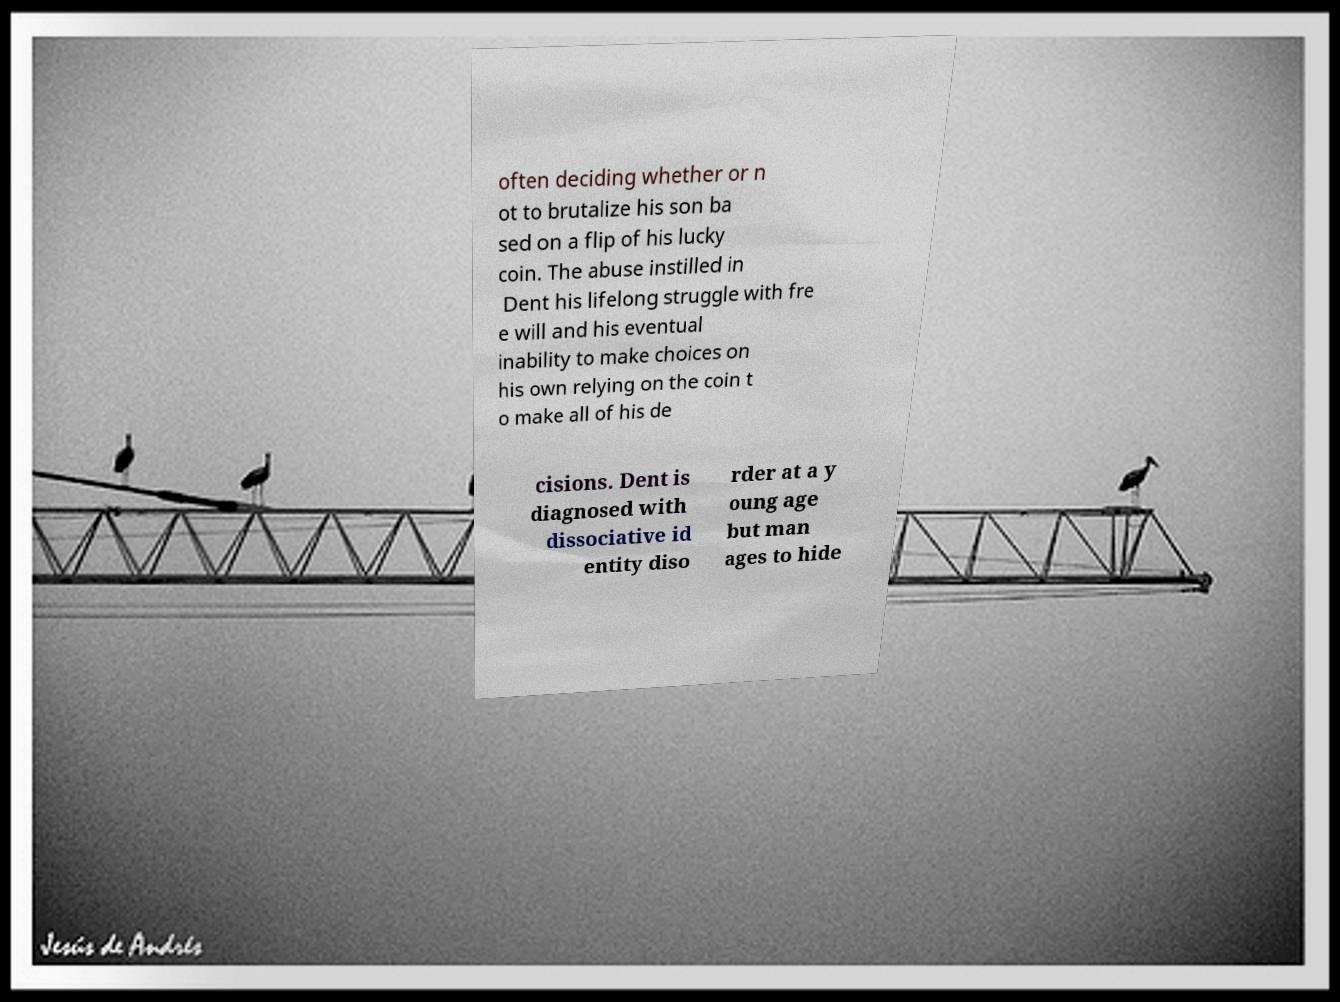Could you extract and type out the text from this image? often deciding whether or n ot to brutalize his son ba sed on a flip of his lucky coin. The abuse instilled in Dent his lifelong struggle with fre e will and his eventual inability to make choices on his own relying on the coin t o make all of his de cisions. Dent is diagnosed with dissociative id entity diso rder at a y oung age but man ages to hide 